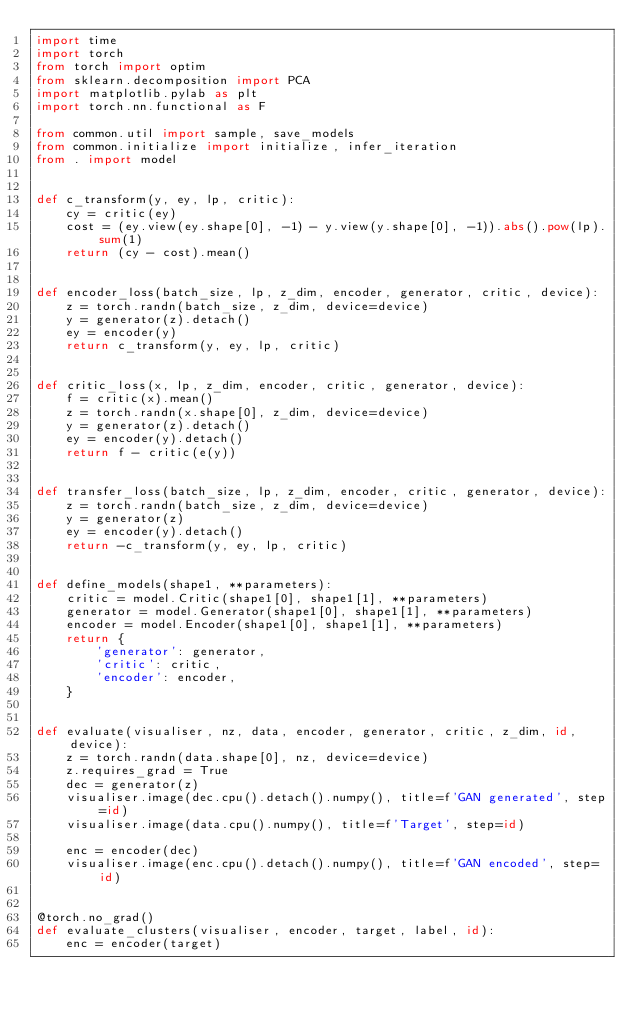<code> <loc_0><loc_0><loc_500><loc_500><_Python_>import time
import torch
from torch import optim
from sklearn.decomposition import PCA
import matplotlib.pylab as plt
import torch.nn.functional as F

from common.util import sample, save_models
from common.initialize import initialize, infer_iteration
from . import model


def c_transform(y, ey, lp, critic):
    cy = critic(ey)
    cost = (ey.view(ey.shape[0], -1) - y.view(y.shape[0], -1)).abs().pow(lp).sum(1)
    return (cy - cost).mean()


def encoder_loss(batch_size, lp, z_dim, encoder, generator, critic, device):
    z = torch.randn(batch_size, z_dim, device=device)
    y = generator(z).detach()
    ey = encoder(y)
    return c_transform(y, ey, lp, critic)


def critic_loss(x, lp, z_dim, encoder, critic, generator, device):
    f = critic(x).mean()
    z = torch.randn(x.shape[0], z_dim, device=device)
    y = generator(z).detach()
    ey = encoder(y).detach()
    return f - critic(e(y))


def transfer_loss(batch_size, lp, z_dim, encoder, critic, generator, device):
    z = torch.randn(batch_size, z_dim, device=device)
    y = generator(z)
    ey = encoder(y).detach()
    return -c_transform(y, ey, lp, critic)


def define_models(shape1, **parameters):
    critic = model.Critic(shape1[0], shape1[1], **parameters)
    generator = model.Generator(shape1[0], shape1[1], **parameters)
    encoder = model.Encoder(shape1[0], shape1[1], **parameters)
    return {
        'generator': generator,
        'critic': critic,
        'encoder': encoder,
    }


def evaluate(visualiser, nz, data, encoder, generator, critic, z_dim, id, device):
    z = torch.randn(data.shape[0], nz, device=device)
    z.requires_grad = True
    dec = generator(z)
    visualiser.image(dec.cpu().detach().numpy(), title=f'GAN generated', step=id)
    visualiser.image(data.cpu().numpy(), title=f'Target', step=id)

    enc = encoder(dec)
    visualiser.image(enc.cpu().detach().numpy(), title=f'GAN encoded', step=id)


@torch.no_grad()
def evaluate_clusters(visualiser, encoder, target, label, id):
    enc = encoder(target)</code> 